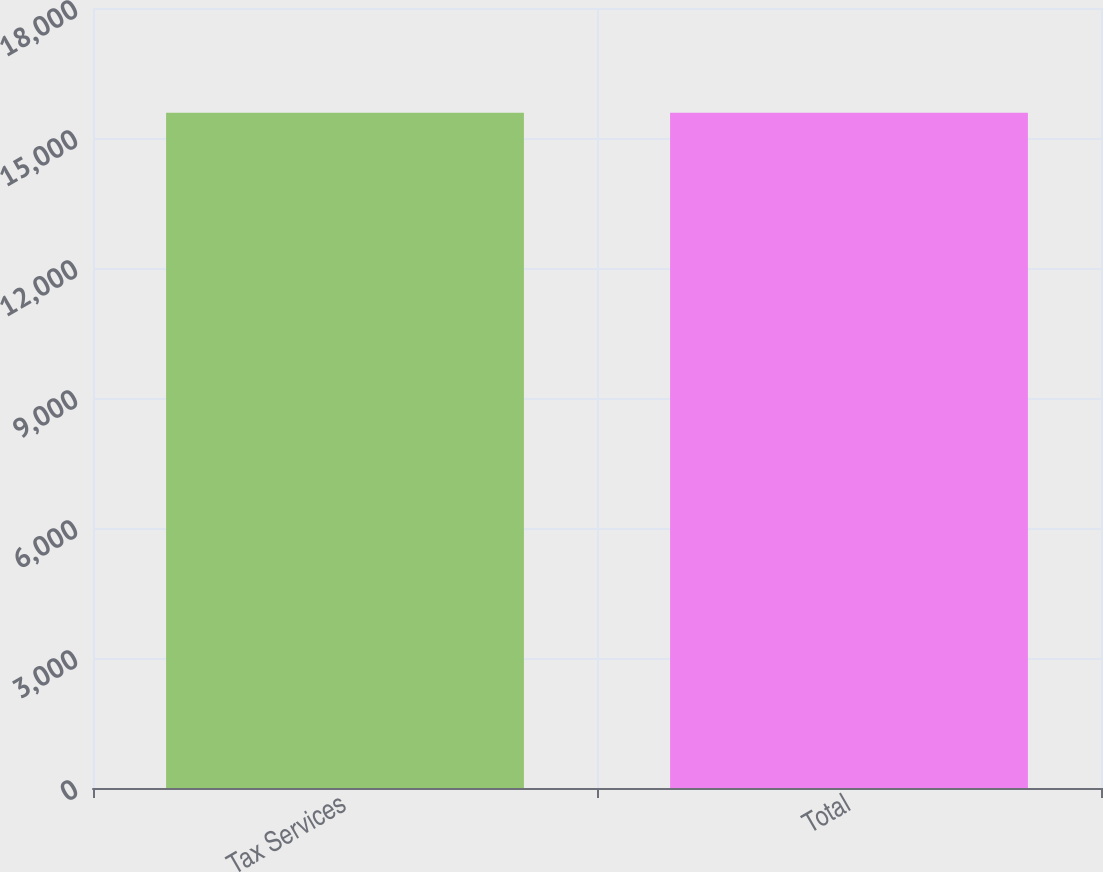Convert chart. <chart><loc_0><loc_0><loc_500><loc_500><bar_chart><fcel>Tax Services<fcel>Total<nl><fcel>15582<fcel>15582.1<nl></chart> 